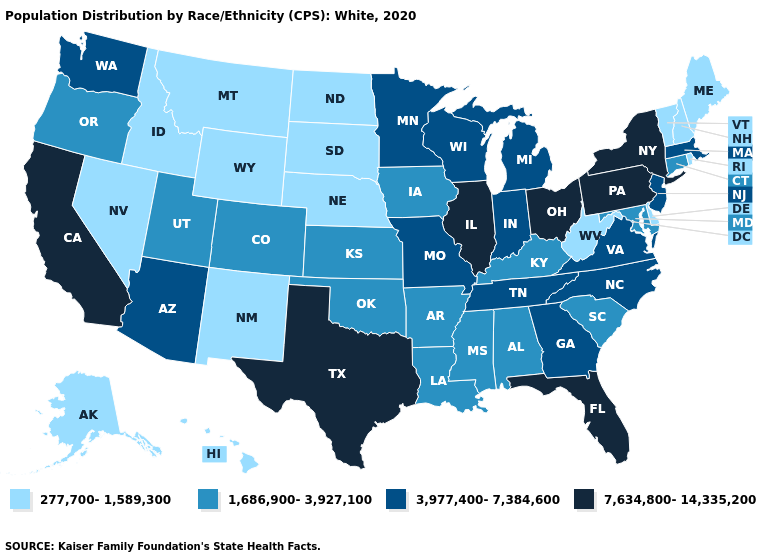What is the value of New Jersey?
Be succinct. 3,977,400-7,384,600. Name the states that have a value in the range 1,686,900-3,927,100?
Keep it brief. Alabama, Arkansas, Colorado, Connecticut, Iowa, Kansas, Kentucky, Louisiana, Maryland, Mississippi, Oklahoma, Oregon, South Carolina, Utah. Does Pennsylvania have the highest value in the USA?
Keep it brief. Yes. Name the states that have a value in the range 3,977,400-7,384,600?
Keep it brief. Arizona, Georgia, Indiana, Massachusetts, Michigan, Minnesota, Missouri, New Jersey, North Carolina, Tennessee, Virginia, Washington, Wisconsin. Does the first symbol in the legend represent the smallest category?
Short answer required. Yes. Does the map have missing data?
Concise answer only. No. How many symbols are there in the legend?
Keep it brief. 4. Name the states that have a value in the range 7,634,800-14,335,200?
Answer briefly. California, Florida, Illinois, New York, Ohio, Pennsylvania, Texas. Name the states that have a value in the range 7,634,800-14,335,200?
Concise answer only. California, Florida, Illinois, New York, Ohio, Pennsylvania, Texas. What is the value of Iowa?
Concise answer only. 1,686,900-3,927,100. Does New Mexico have the same value as Washington?
Write a very short answer. No. Is the legend a continuous bar?
Write a very short answer. No. What is the value of Kentucky?
Short answer required. 1,686,900-3,927,100. Among the states that border Delaware , does Pennsylvania have the lowest value?
Give a very brief answer. No. What is the highest value in the MidWest ?
Short answer required. 7,634,800-14,335,200. 